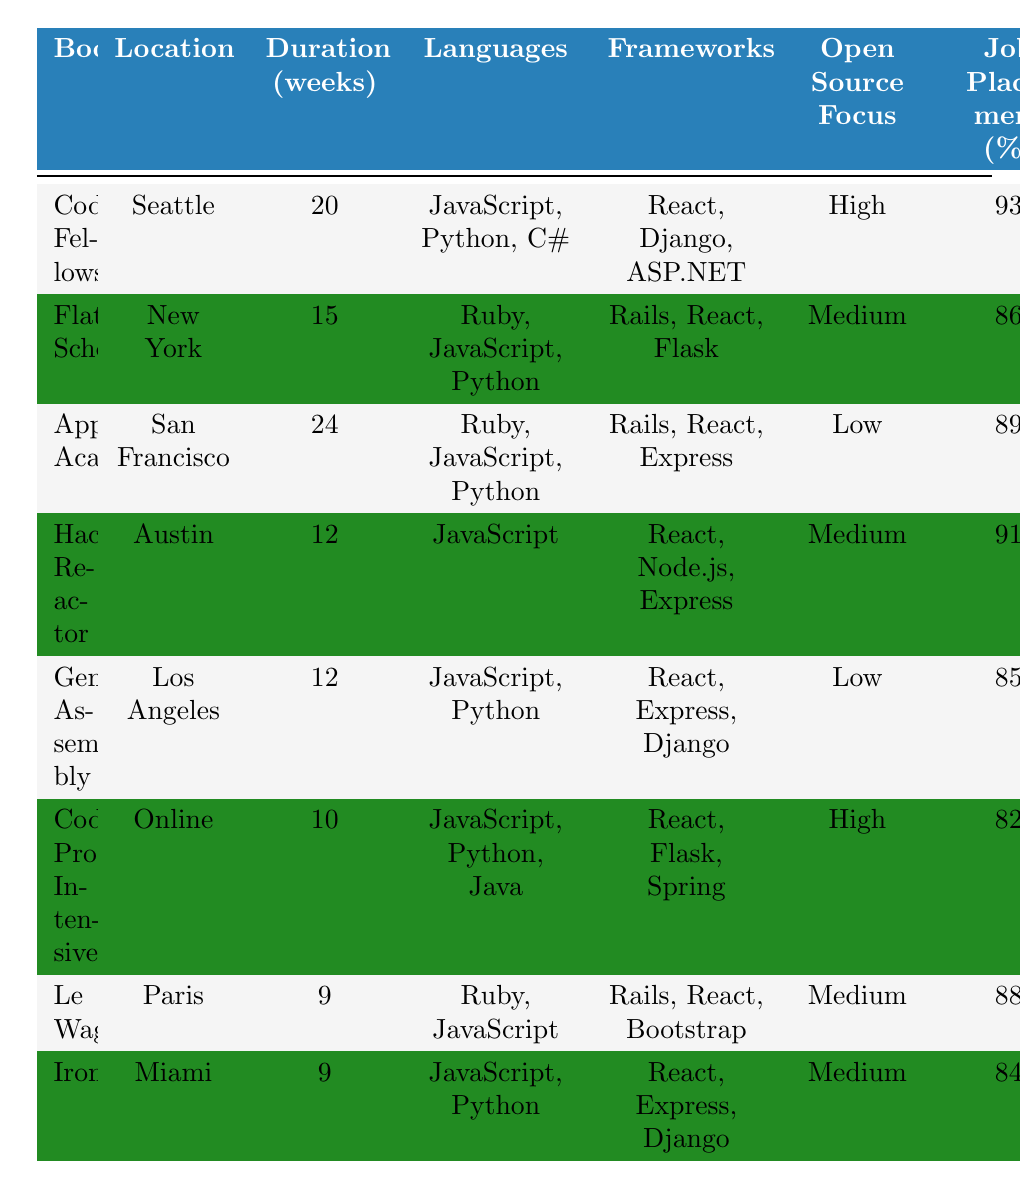What is the location of Ironhack? According to the table, Ironhack is located in Miami.
Answer: Miami Which bootcamp has the highest job placement rate? Referencing the job placement rates listed in the table, Code Fellows has the highest rate at 93%.
Answer: 93% What programming languages are taught at Flatiron School? The table specifies that Flatiron School teaches Ruby, JavaScript, and Python.
Answer: Ruby, JavaScript, Python How many weeks does Codecademy Pro Intensive last? The duration for Codecademy Pro Intensive is indicated as 10 weeks in the table.
Answer: 10 weeks Is the open-source focus of General Assembly low? The table shows that General Assembly has a low open-source focus, verifying that the statement is true.
Answer: Yes What is the average job placement rate of the bootcamps in Miami? The two bootcamps in Miami are Ironhack (84%) and Hack Reactor (91%). Thus, the average is (84 + 91) / 2 = 87.5%.
Answer: 87.5% Which bootcamp teaches both Java and Python? Looking through the programming languages offered, Codecademy Pro Intensive is the only bootcamp that teaches both Java and Python.
Answer: Codecademy Pro Intensive How many bootcamps teach React as a framework? By counting the instances in the framework column, six bootcamps (Code Fellows, Flatiron School, Hack Reactor, General Assembly, Codecademy Pro Intensive, Le Wagon, Ironhack) teach React.
Answer: 6 Does App Academy have a greater duration than Le Wagon? App Academy lasts 24 weeks while Le Wagon lasts 9 weeks. Since 24 is greater than 9, the statement is true.
Answer: Yes What is the ratio of the bootcamp durations for Codecademy Pro Intensive to App Academy? Codecademy Pro Intensive lasts for 10 weeks and App Academy for 24 weeks. The ratio is 10:24 or simplified, 5:12.
Answer: 5:12 